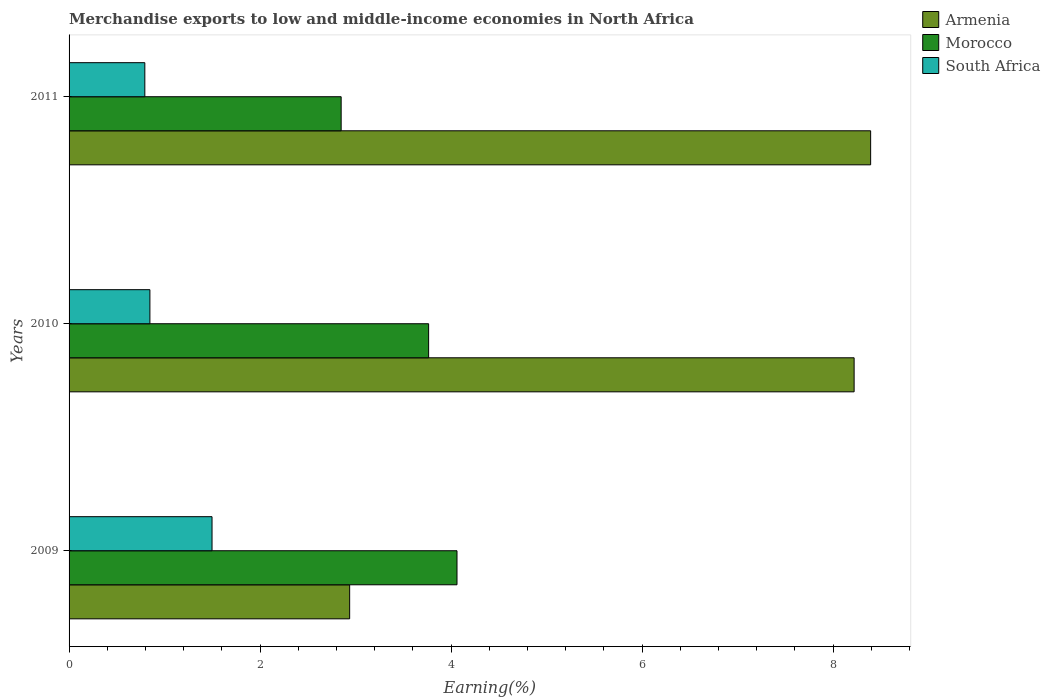Are the number of bars per tick equal to the number of legend labels?
Provide a succinct answer. Yes. How many bars are there on the 1st tick from the top?
Ensure brevity in your answer.  3. What is the label of the 2nd group of bars from the top?
Make the answer very short. 2010. In how many cases, is the number of bars for a given year not equal to the number of legend labels?
Offer a terse response. 0. What is the percentage of amount earned from merchandise exports in Morocco in 2011?
Provide a succinct answer. 2.85. Across all years, what is the maximum percentage of amount earned from merchandise exports in Armenia?
Your response must be concise. 8.39. Across all years, what is the minimum percentage of amount earned from merchandise exports in Morocco?
Your response must be concise. 2.85. What is the total percentage of amount earned from merchandise exports in Armenia in the graph?
Offer a terse response. 19.55. What is the difference between the percentage of amount earned from merchandise exports in Armenia in 2010 and that in 2011?
Your response must be concise. -0.17. What is the difference between the percentage of amount earned from merchandise exports in Morocco in 2010 and the percentage of amount earned from merchandise exports in Armenia in 2011?
Keep it short and to the point. -4.63. What is the average percentage of amount earned from merchandise exports in South Africa per year?
Make the answer very short. 1.05. In the year 2009, what is the difference between the percentage of amount earned from merchandise exports in Morocco and percentage of amount earned from merchandise exports in South Africa?
Ensure brevity in your answer.  2.56. In how many years, is the percentage of amount earned from merchandise exports in Morocco greater than 7.2 %?
Offer a very short reply. 0. What is the ratio of the percentage of amount earned from merchandise exports in South Africa in 2010 to that in 2011?
Make the answer very short. 1.07. Is the percentage of amount earned from merchandise exports in South Africa in 2010 less than that in 2011?
Provide a succinct answer. No. Is the difference between the percentage of amount earned from merchandise exports in Morocco in 2009 and 2010 greater than the difference between the percentage of amount earned from merchandise exports in South Africa in 2009 and 2010?
Make the answer very short. No. What is the difference between the highest and the second highest percentage of amount earned from merchandise exports in South Africa?
Provide a succinct answer. 0.65. What is the difference between the highest and the lowest percentage of amount earned from merchandise exports in Armenia?
Your response must be concise. 5.45. In how many years, is the percentage of amount earned from merchandise exports in South Africa greater than the average percentage of amount earned from merchandise exports in South Africa taken over all years?
Offer a terse response. 1. Is the sum of the percentage of amount earned from merchandise exports in Armenia in 2009 and 2010 greater than the maximum percentage of amount earned from merchandise exports in South Africa across all years?
Keep it short and to the point. Yes. What does the 2nd bar from the top in 2009 represents?
Make the answer very short. Morocco. What does the 3rd bar from the bottom in 2010 represents?
Make the answer very short. South Africa. How many bars are there?
Provide a succinct answer. 9. Are all the bars in the graph horizontal?
Provide a short and direct response. Yes. How many years are there in the graph?
Make the answer very short. 3. Does the graph contain any zero values?
Offer a terse response. No. How many legend labels are there?
Your answer should be compact. 3. What is the title of the graph?
Offer a terse response. Merchandise exports to low and middle-income economies in North Africa. What is the label or title of the X-axis?
Offer a terse response. Earning(%). What is the label or title of the Y-axis?
Your answer should be very brief. Years. What is the Earning(%) in Armenia in 2009?
Your response must be concise. 2.94. What is the Earning(%) of Morocco in 2009?
Make the answer very short. 4.06. What is the Earning(%) of South Africa in 2009?
Your answer should be compact. 1.5. What is the Earning(%) in Armenia in 2010?
Your answer should be very brief. 8.22. What is the Earning(%) in Morocco in 2010?
Provide a short and direct response. 3.76. What is the Earning(%) of South Africa in 2010?
Your response must be concise. 0.85. What is the Earning(%) in Armenia in 2011?
Ensure brevity in your answer.  8.39. What is the Earning(%) in Morocco in 2011?
Ensure brevity in your answer.  2.85. What is the Earning(%) of South Africa in 2011?
Your response must be concise. 0.79. Across all years, what is the maximum Earning(%) of Armenia?
Provide a succinct answer. 8.39. Across all years, what is the maximum Earning(%) in Morocco?
Give a very brief answer. 4.06. Across all years, what is the maximum Earning(%) of South Africa?
Provide a short and direct response. 1.5. Across all years, what is the minimum Earning(%) in Armenia?
Offer a very short reply. 2.94. Across all years, what is the minimum Earning(%) in Morocco?
Your answer should be very brief. 2.85. Across all years, what is the minimum Earning(%) of South Africa?
Ensure brevity in your answer.  0.79. What is the total Earning(%) in Armenia in the graph?
Ensure brevity in your answer.  19.55. What is the total Earning(%) in Morocco in the graph?
Your answer should be very brief. 10.67. What is the total Earning(%) of South Africa in the graph?
Your answer should be compact. 3.14. What is the difference between the Earning(%) of Armenia in 2009 and that in 2010?
Your response must be concise. -5.28. What is the difference between the Earning(%) in Morocco in 2009 and that in 2010?
Make the answer very short. 0.3. What is the difference between the Earning(%) of South Africa in 2009 and that in 2010?
Your answer should be very brief. 0.65. What is the difference between the Earning(%) of Armenia in 2009 and that in 2011?
Keep it short and to the point. -5.45. What is the difference between the Earning(%) of Morocco in 2009 and that in 2011?
Offer a very short reply. 1.21. What is the difference between the Earning(%) of South Africa in 2009 and that in 2011?
Make the answer very short. 0.7. What is the difference between the Earning(%) in Armenia in 2010 and that in 2011?
Ensure brevity in your answer.  -0.17. What is the difference between the Earning(%) of Morocco in 2010 and that in 2011?
Provide a short and direct response. 0.92. What is the difference between the Earning(%) in South Africa in 2010 and that in 2011?
Give a very brief answer. 0.05. What is the difference between the Earning(%) in Armenia in 2009 and the Earning(%) in Morocco in 2010?
Offer a very short reply. -0.83. What is the difference between the Earning(%) of Armenia in 2009 and the Earning(%) of South Africa in 2010?
Offer a terse response. 2.09. What is the difference between the Earning(%) of Morocco in 2009 and the Earning(%) of South Africa in 2010?
Offer a very short reply. 3.22. What is the difference between the Earning(%) of Armenia in 2009 and the Earning(%) of Morocco in 2011?
Ensure brevity in your answer.  0.09. What is the difference between the Earning(%) in Armenia in 2009 and the Earning(%) in South Africa in 2011?
Your answer should be very brief. 2.14. What is the difference between the Earning(%) of Morocco in 2009 and the Earning(%) of South Africa in 2011?
Your response must be concise. 3.27. What is the difference between the Earning(%) in Armenia in 2010 and the Earning(%) in Morocco in 2011?
Offer a terse response. 5.37. What is the difference between the Earning(%) of Armenia in 2010 and the Earning(%) of South Africa in 2011?
Offer a terse response. 7.43. What is the difference between the Earning(%) of Morocco in 2010 and the Earning(%) of South Africa in 2011?
Provide a short and direct response. 2.97. What is the average Earning(%) of Armenia per year?
Your answer should be compact. 6.52. What is the average Earning(%) in Morocco per year?
Provide a succinct answer. 3.56. What is the average Earning(%) of South Africa per year?
Keep it short and to the point. 1.05. In the year 2009, what is the difference between the Earning(%) of Armenia and Earning(%) of Morocco?
Your answer should be very brief. -1.12. In the year 2009, what is the difference between the Earning(%) of Armenia and Earning(%) of South Africa?
Offer a terse response. 1.44. In the year 2009, what is the difference between the Earning(%) of Morocco and Earning(%) of South Africa?
Provide a succinct answer. 2.56. In the year 2010, what is the difference between the Earning(%) in Armenia and Earning(%) in Morocco?
Ensure brevity in your answer.  4.45. In the year 2010, what is the difference between the Earning(%) in Armenia and Earning(%) in South Africa?
Your answer should be compact. 7.37. In the year 2010, what is the difference between the Earning(%) in Morocco and Earning(%) in South Africa?
Your response must be concise. 2.92. In the year 2011, what is the difference between the Earning(%) in Armenia and Earning(%) in Morocco?
Your response must be concise. 5.54. In the year 2011, what is the difference between the Earning(%) in Armenia and Earning(%) in South Africa?
Give a very brief answer. 7.6. In the year 2011, what is the difference between the Earning(%) of Morocco and Earning(%) of South Africa?
Your answer should be compact. 2.06. What is the ratio of the Earning(%) of Armenia in 2009 to that in 2010?
Provide a short and direct response. 0.36. What is the ratio of the Earning(%) of Morocco in 2009 to that in 2010?
Make the answer very short. 1.08. What is the ratio of the Earning(%) in South Africa in 2009 to that in 2010?
Your answer should be compact. 1.77. What is the ratio of the Earning(%) in Morocco in 2009 to that in 2011?
Your response must be concise. 1.43. What is the ratio of the Earning(%) of South Africa in 2009 to that in 2011?
Your answer should be very brief. 1.89. What is the ratio of the Earning(%) in Armenia in 2010 to that in 2011?
Ensure brevity in your answer.  0.98. What is the ratio of the Earning(%) in Morocco in 2010 to that in 2011?
Provide a succinct answer. 1.32. What is the ratio of the Earning(%) of South Africa in 2010 to that in 2011?
Your answer should be very brief. 1.07. What is the difference between the highest and the second highest Earning(%) of Armenia?
Provide a succinct answer. 0.17. What is the difference between the highest and the second highest Earning(%) of Morocco?
Offer a terse response. 0.3. What is the difference between the highest and the second highest Earning(%) in South Africa?
Your response must be concise. 0.65. What is the difference between the highest and the lowest Earning(%) of Armenia?
Your answer should be very brief. 5.45. What is the difference between the highest and the lowest Earning(%) in Morocco?
Give a very brief answer. 1.21. What is the difference between the highest and the lowest Earning(%) in South Africa?
Offer a terse response. 0.7. 